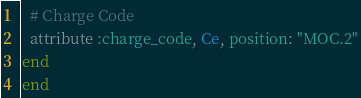Convert code to text. <code><loc_0><loc_0><loc_500><loc_500><_Ruby_>  # Charge Code
  attribute :charge_code, Ce, position: "MOC.2"
end
end</code> 